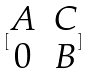<formula> <loc_0><loc_0><loc_500><loc_500>[ \begin{matrix} A & C \\ 0 & B \end{matrix} ]</formula> 